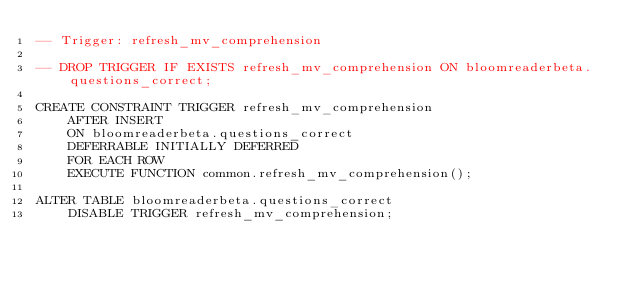<code> <loc_0><loc_0><loc_500><loc_500><_SQL_>-- Trigger: refresh_mv_comprehension

-- DROP TRIGGER IF EXISTS refresh_mv_comprehension ON bloomreaderbeta.questions_correct;

CREATE CONSTRAINT TRIGGER refresh_mv_comprehension
    AFTER INSERT
    ON bloomreaderbeta.questions_correct
    DEFERRABLE INITIALLY DEFERRED
    FOR EACH ROW
    EXECUTE FUNCTION common.refresh_mv_comprehension();

ALTER TABLE bloomreaderbeta.questions_correct
    DISABLE TRIGGER refresh_mv_comprehension;</code> 